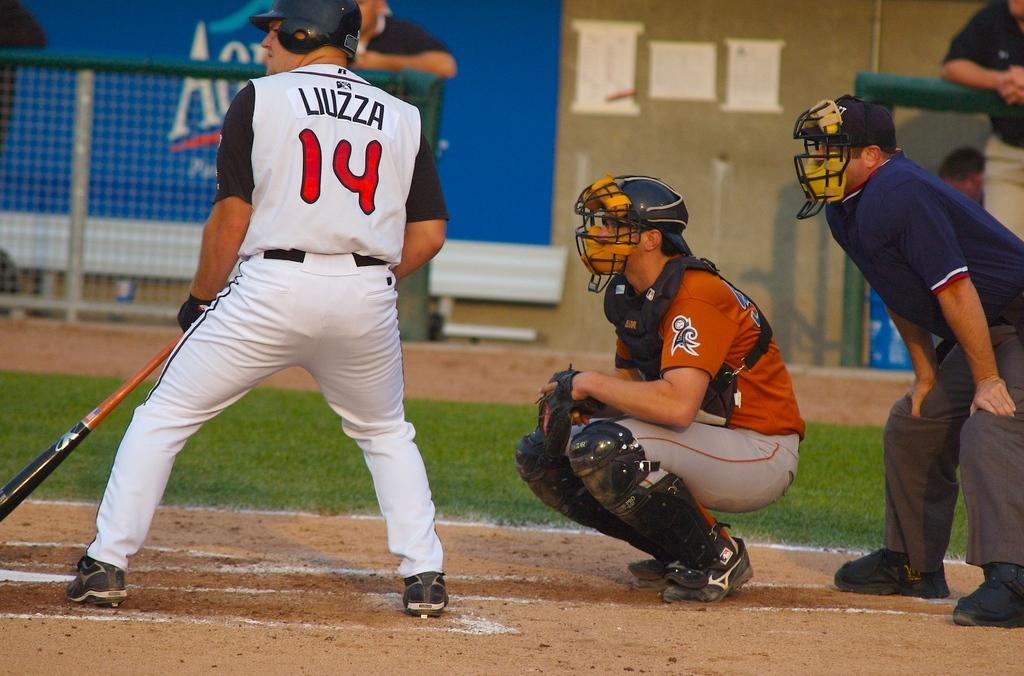<image>
Describe the image concisely. A baseball player wearing a number 14 jersey is batting. 